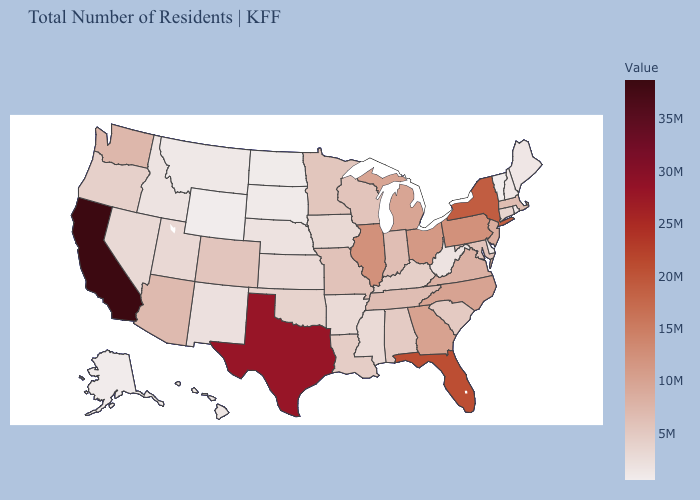Does New Jersey have a higher value than California?
Quick response, please. No. Which states have the lowest value in the USA?
Write a very short answer. Wyoming. Which states have the lowest value in the Northeast?
Answer briefly. Vermont. Does California have the highest value in the West?
Keep it brief. Yes. Does Colorado have the lowest value in the West?
Quick response, please. No. Which states hav the highest value in the West?
Keep it brief. California. 